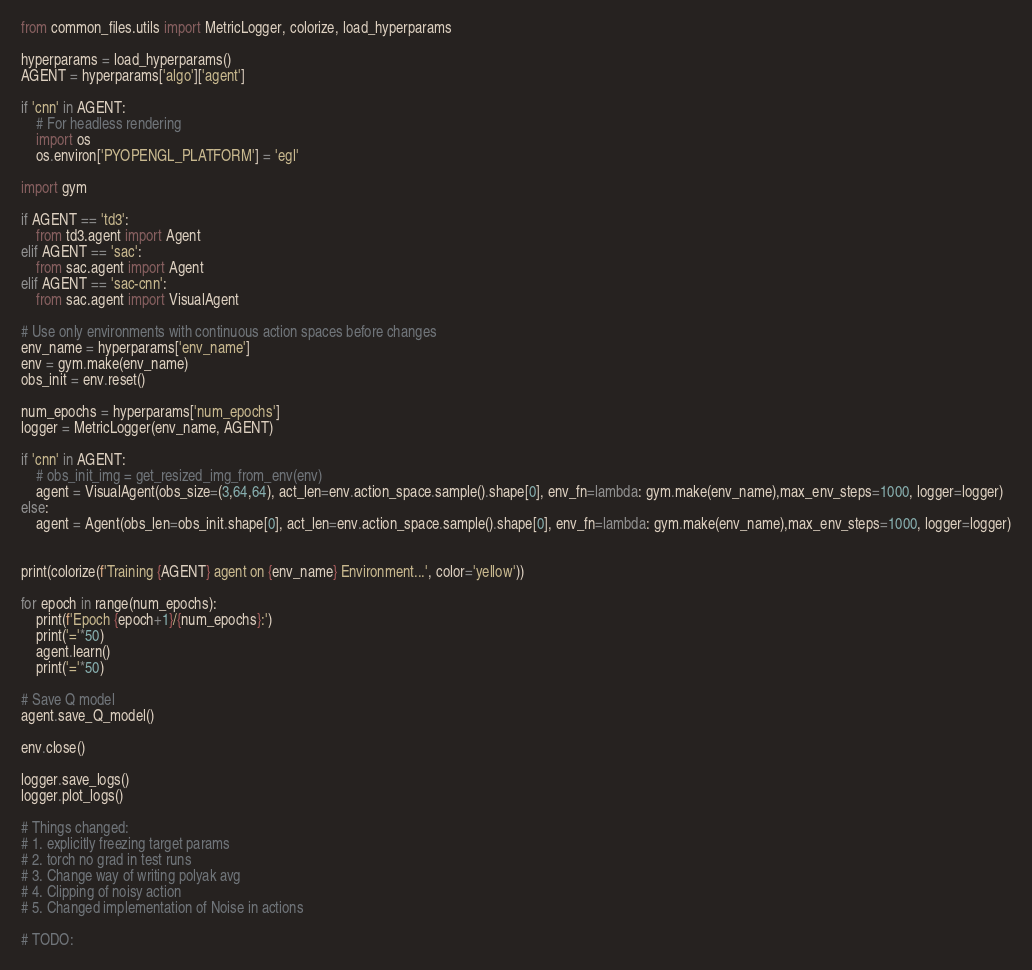<code> <loc_0><loc_0><loc_500><loc_500><_Python_>from common_files.utils import MetricLogger, colorize, load_hyperparams

hyperparams = load_hyperparams()
AGENT = hyperparams['algo']['agent']

if 'cnn' in AGENT:
    # For headless rendering
    import os
    os.environ['PYOPENGL_PLATFORM'] = 'egl'

import gym

if AGENT == 'td3':
    from td3.agent import Agent
elif AGENT == 'sac':
    from sac.agent import Agent
elif AGENT == 'sac-cnn':
    from sac.agent import VisualAgent

# Use only environments with continuous action spaces before changes
env_name = hyperparams['env_name']
env = gym.make(env_name)
obs_init = env.reset()

num_epochs = hyperparams['num_epochs']
logger = MetricLogger(env_name, AGENT)

if 'cnn' in AGENT:
    # obs_init_img = get_resized_img_from_env(env)
    agent = VisualAgent(obs_size=(3,64,64), act_len=env.action_space.sample().shape[0], env_fn=lambda: gym.make(env_name),max_env_steps=1000, logger=logger)
else:
    agent = Agent(obs_len=obs_init.shape[0], act_len=env.action_space.sample().shape[0], env_fn=lambda: gym.make(env_name),max_env_steps=1000, logger=logger)


print(colorize(f'Training {AGENT} agent on {env_name} Environment...', color='yellow'))

for epoch in range(num_epochs):
    print(f'Epoch {epoch+1}/{num_epochs}:')
    print('='*50)
    agent.learn()
    print('='*50)

# Save Q model
agent.save_Q_model()

env.close()

logger.save_logs()
logger.plot_logs()

# Things changed:
# 1. explicitly freezing target params
# 2. torch no grad in test runs
# 3. Change way of writing polyak avg
# 4. Clipping of noisy action
# 5. Changed implementation of Noise in actions

# TODO:</code> 